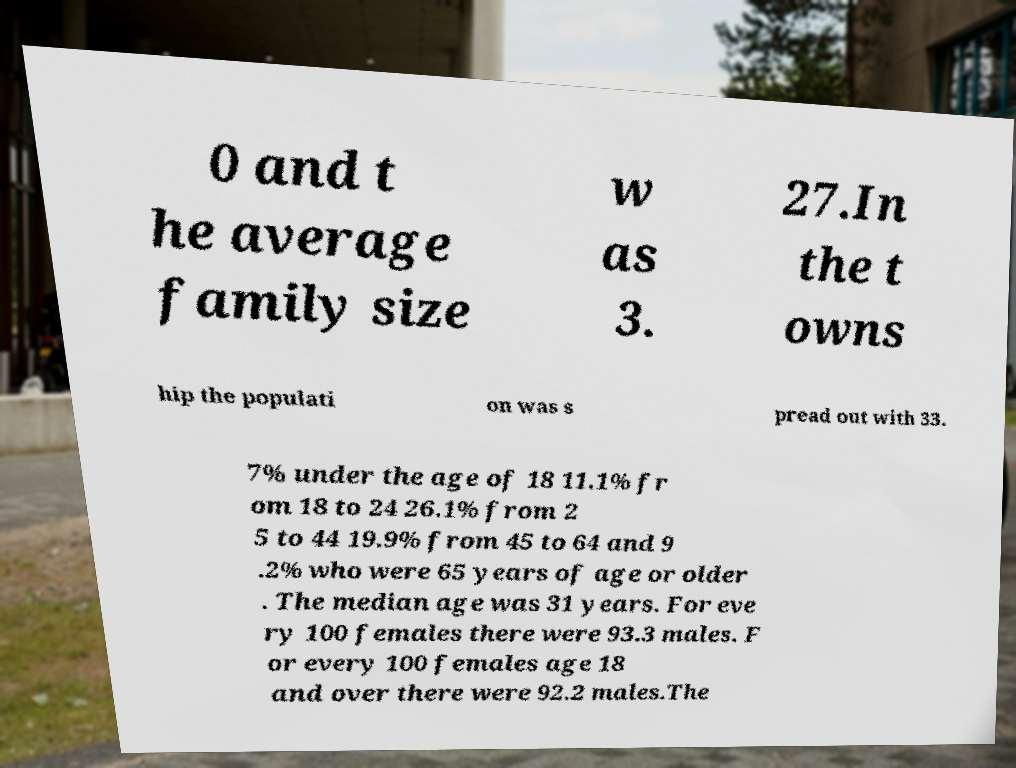I need the written content from this picture converted into text. Can you do that? 0 and t he average family size w as 3. 27.In the t owns hip the populati on was s pread out with 33. 7% under the age of 18 11.1% fr om 18 to 24 26.1% from 2 5 to 44 19.9% from 45 to 64 and 9 .2% who were 65 years of age or older . The median age was 31 years. For eve ry 100 females there were 93.3 males. F or every 100 females age 18 and over there were 92.2 males.The 